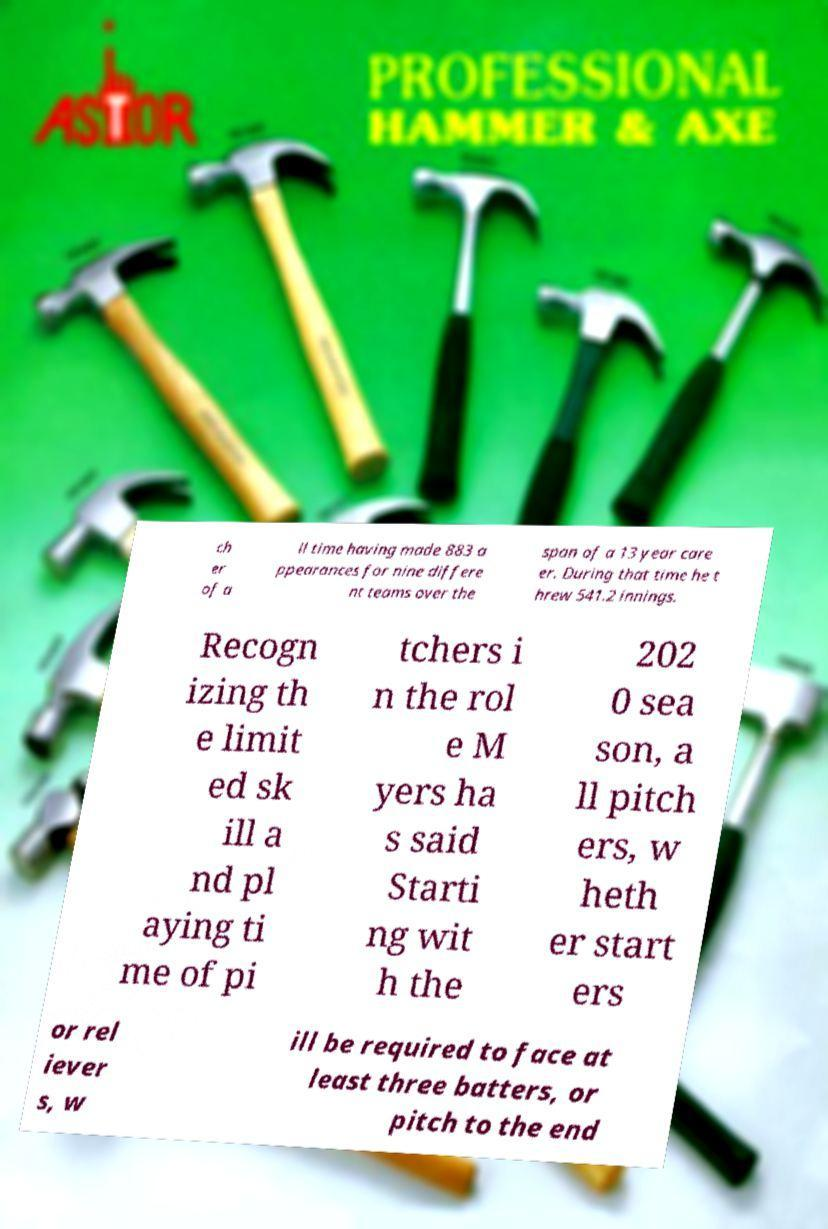Can you read and provide the text displayed in the image?This photo seems to have some interesting text. Can you extract and type it out for me? ch er of a ll time having made 883 a ppearances for nine differe nt teams over the span of a 13 year care er. During that time he t hrew 541.2 innings. Recogn izing th e limit ed sk ill a nd pl aying ti me of pi tchers i n the rol e M yers ha s said Starti ng wit h the 202 0 sea son, a ll pitch ers, w heth er start ers or rel iever s, w ill be required to face at least three batters, or pitch to the end 